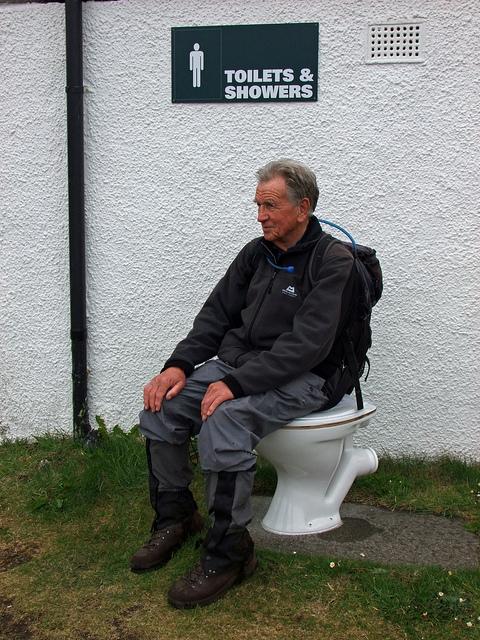Is  this  proper place for a toilet?
Short answer required. No. Is the man using the toilet?
Give a very brief answer. No. What does the sign say?
Short answer required. Toilets & showers. 